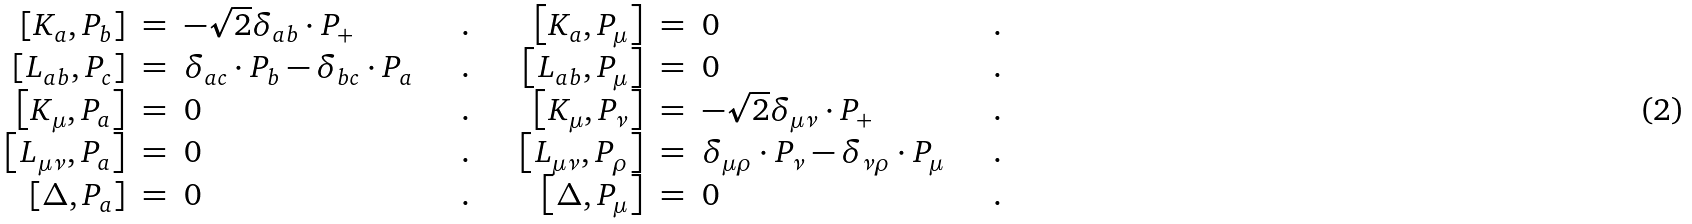<formula> <loc_0><loc_0><loc_500><loc_500>\begin{array} { r c l c r c l c } { { \left [ K _ { a } , P _ { b } \right ] } } & { = } & { { - \sqrt { 2 } \delta _ { a b } \cdot P _ { + } } } & { \quad . \quad } & { { \left [ K _ { a } , P _ { \mu } \right ] } } & { = } & { 0 } & { \quad . } \\ { { \left [ L _ { a b } , P _ { c } \right ] } } & { = } & { { \delta _ { a c } \cdot P _ { b } - \delta _ { b c } \cdot P _ { a } } } & { \quad . \quad } & { { \left [ L _ { a b } , P _ { \mu } \right ] } } & { = } & { 0 } & { \quad . } \\ { { \left [ K _ { \mu } , P _ { a } \right ] } } & { = } & { 0 } & { \quad . \quad } & { { \left [ K _ { \mu } , P _ { \nu } \right ] } } & { = } & { { - \sqrt { 2 } \delta _ { \mu \nu } \cdot P _ { + } } } & { \quad . } \\ { { \left [ L _ { \mu \nu } , P _ { a } \right ] } } & { = } & { 0 } & { \quad . \quad } & { { \left [ L _ { \mu \nu } , P _ { \rho } \right ] } } & { = } & { { \delta _ { \mu \rho } \cdot P _ { \nu } - \delta _ { \nu \rho } \cdot P _ { \mu } } } & { \quad . } \\ { { \left [ \Delta , P _ { a } \right ] } } & { = } & { 0 } & { \quad . \quad } & { { \left [ \Delta , P _ { \mu } \right ] } } & { = } & { 0 } & { \quad . } \end{array}</formula> 